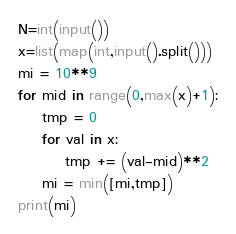<code> <loc_0><loc_0><loc_500><loc_500><_Python_>N=int(input())
x=list(map(int,input().split()))
mi = 10**9
for mid in range(0,max(x)+1):
    tmp = 0
    for val in x:
        tmp += (val-mid)**2
    mi = min([mi,tmp])
print(mi)
</code> 